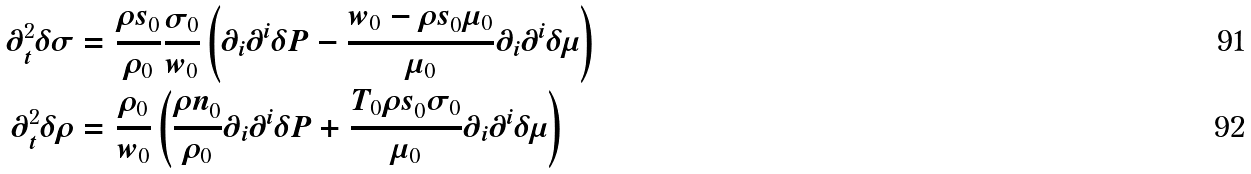Convert formula to latex. <formula><loc_0><loc_0><loc_500><loc_500>\partial _ { t } ^ { 2 } \delta \sigma & = \frac { { \rho s } _ { 0 } } { \rho _ { 0 } } \frac { \sigma _ { 0 } } { w _ { 0 } } \left ( \partial _ { i } \partial ^ { i } \delta P - \frac { w _ { 0 } - { \rho s } _ { 0 } \mu _ { 0 } } { \mu _ { 0 } } \partial _ { i } \partial ^ { i } \delta \mu \right ) \\ \partial _ { t } ^ { 2 } \delta \rho & = \frac { \rho _ { 0 } } { w _ { 0 } } \left ( \frac { { \rho n } _ { 0 } } { \rho _ { 0 } } \partial _ { i } \partial ^ { i } \delta P + \frac { T _ { 0 } { \rho s } _ { 0 } \sigma _ { 0 } } { \mu _ { 0 } } \partial _ { i } \partial ^ { i } \delta \mu \right )</formula> 